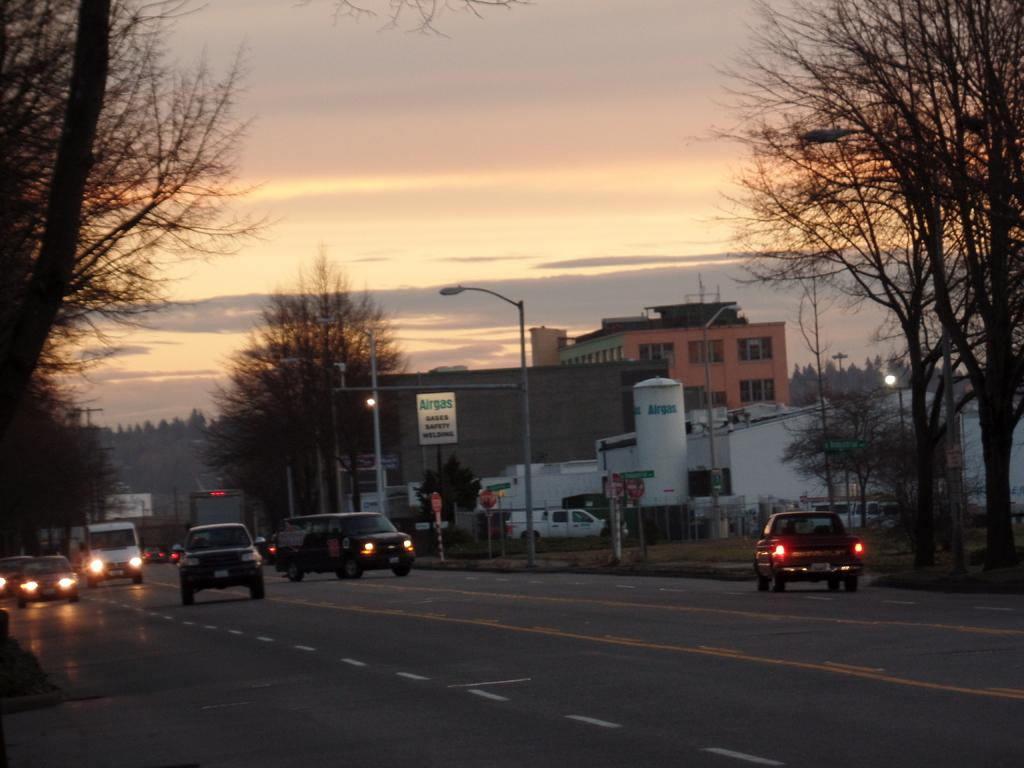What can be seen on the road in the image? There are vehicles on the road in the image. What type of vegetation is present alongside the road? Trees are present on either side of the road. What can be seen in the background of the image? There are buildings in the background of the image. What is visible above the road and buildings? The sky is visible in the image. What can be observed in the sky? Clouds are present in the sky. What type of drink is being advertised on the side of the road in the image? There is no drink being advertised on the side of the road in the image. What word is written on the side of the building in the image? There is no specific word mentioned in the provided facts, so we cannot answer this question. 